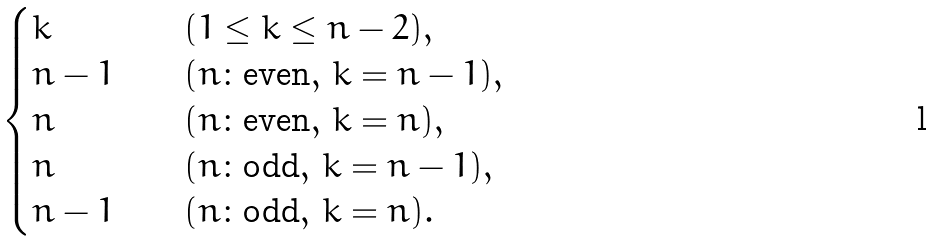<formula> <loc_0><loc_0><loc_500><loc_500>\begin{cases} k \quad & ( 1 \leq k \leq n - 2 ) , \\ n - 1 \quad & ( n \colon \text {even} , \, k = n - 1 ) , \\ n \quad & ( n \colon \text {even} , \, k = n ) , \\ n \quad & ( n \colon \text {odd} , \, k = n - 1 ) , \\ n - 1 \quad & ( n \colon \text {odd} , \, k = n ) . \end{cases}</formula> 